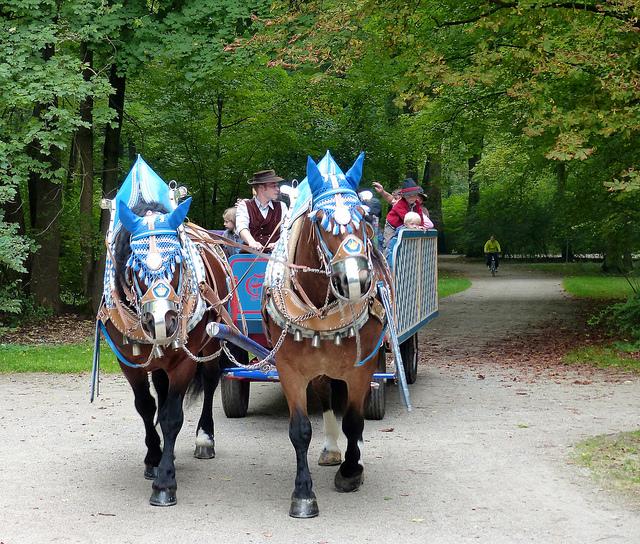What is on the horses' heads?
Short answer required. Hats. Is anyone riding a bicycle?
Quick response, please. Yes. How many people are there?
Answer briefly. 4. 